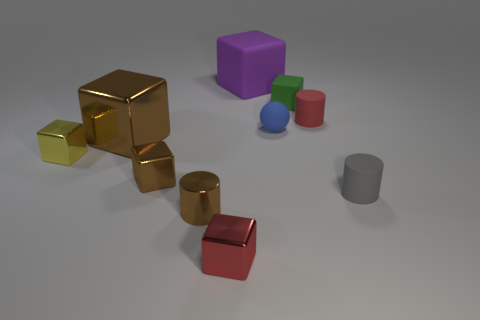What color is the matte thing that is in front of the yellow shiny block? gray 